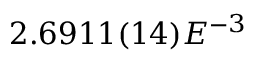Convert formula to latex. <formula><loc_0><loc_0><loc_500><loc_500>2 . 6 9 1 1 ( 1 4 ) E ^ { - 3 }</formula> 